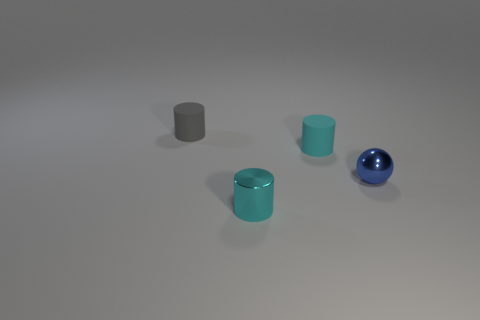Is there a cyan object of the same shape as the tiny gray object?
Your answer should be very brief. Yes. What is the material of the cyan object in front of the small cyan object to the right of the tiny cyan object in front of the blue metal ball?
Give a very brief answer. Metal. Is the tiny blue thing made of the same material as the tiny gray cylinder?
Provide a succinct answer. No. How many cylinders are small blue metal things or small cyan objects?
Make the answer very short. 2. What color is the small metallic object that is in front of the blue sphere?
Keep it short and to the point. Cyan. How many rubber objects are either tiny objects or small blue objects?
Make the answer very short. 2. What material is the tiny cyan cylinder that is on the left side of the rubber object that is right of the gray rubber cylinder?
Your answer should be very brief. Metal. There is another small cylinder that is the same color as the shiny cylinder; what is it made of?
Keep it short and to the point. Rubber. What is the color of the metallic cylinder?
Ensure brevity in your answer.  Cyan. There is a tiny sphere in front of the gray thing; are there any blue shiny balls that are left of it?
Make the answer very short. No. 